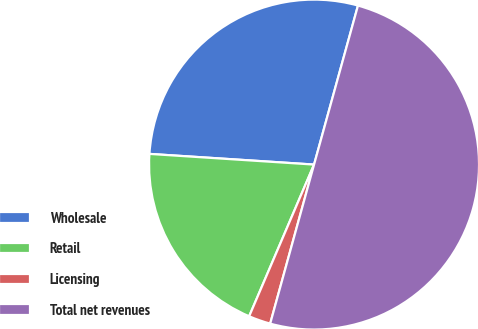Convert chart to OTSL. <chart><loc_0><loc_0><loc_500><loc_500><pie_chart><fcel>Wholesale<fcel>Retail<fcel>Licensing<fcel>Total net revenues<nl><fcel>28.26%<fcel>19.6%<fcel>2.15%<fcel>50.0%<nl></chart> 